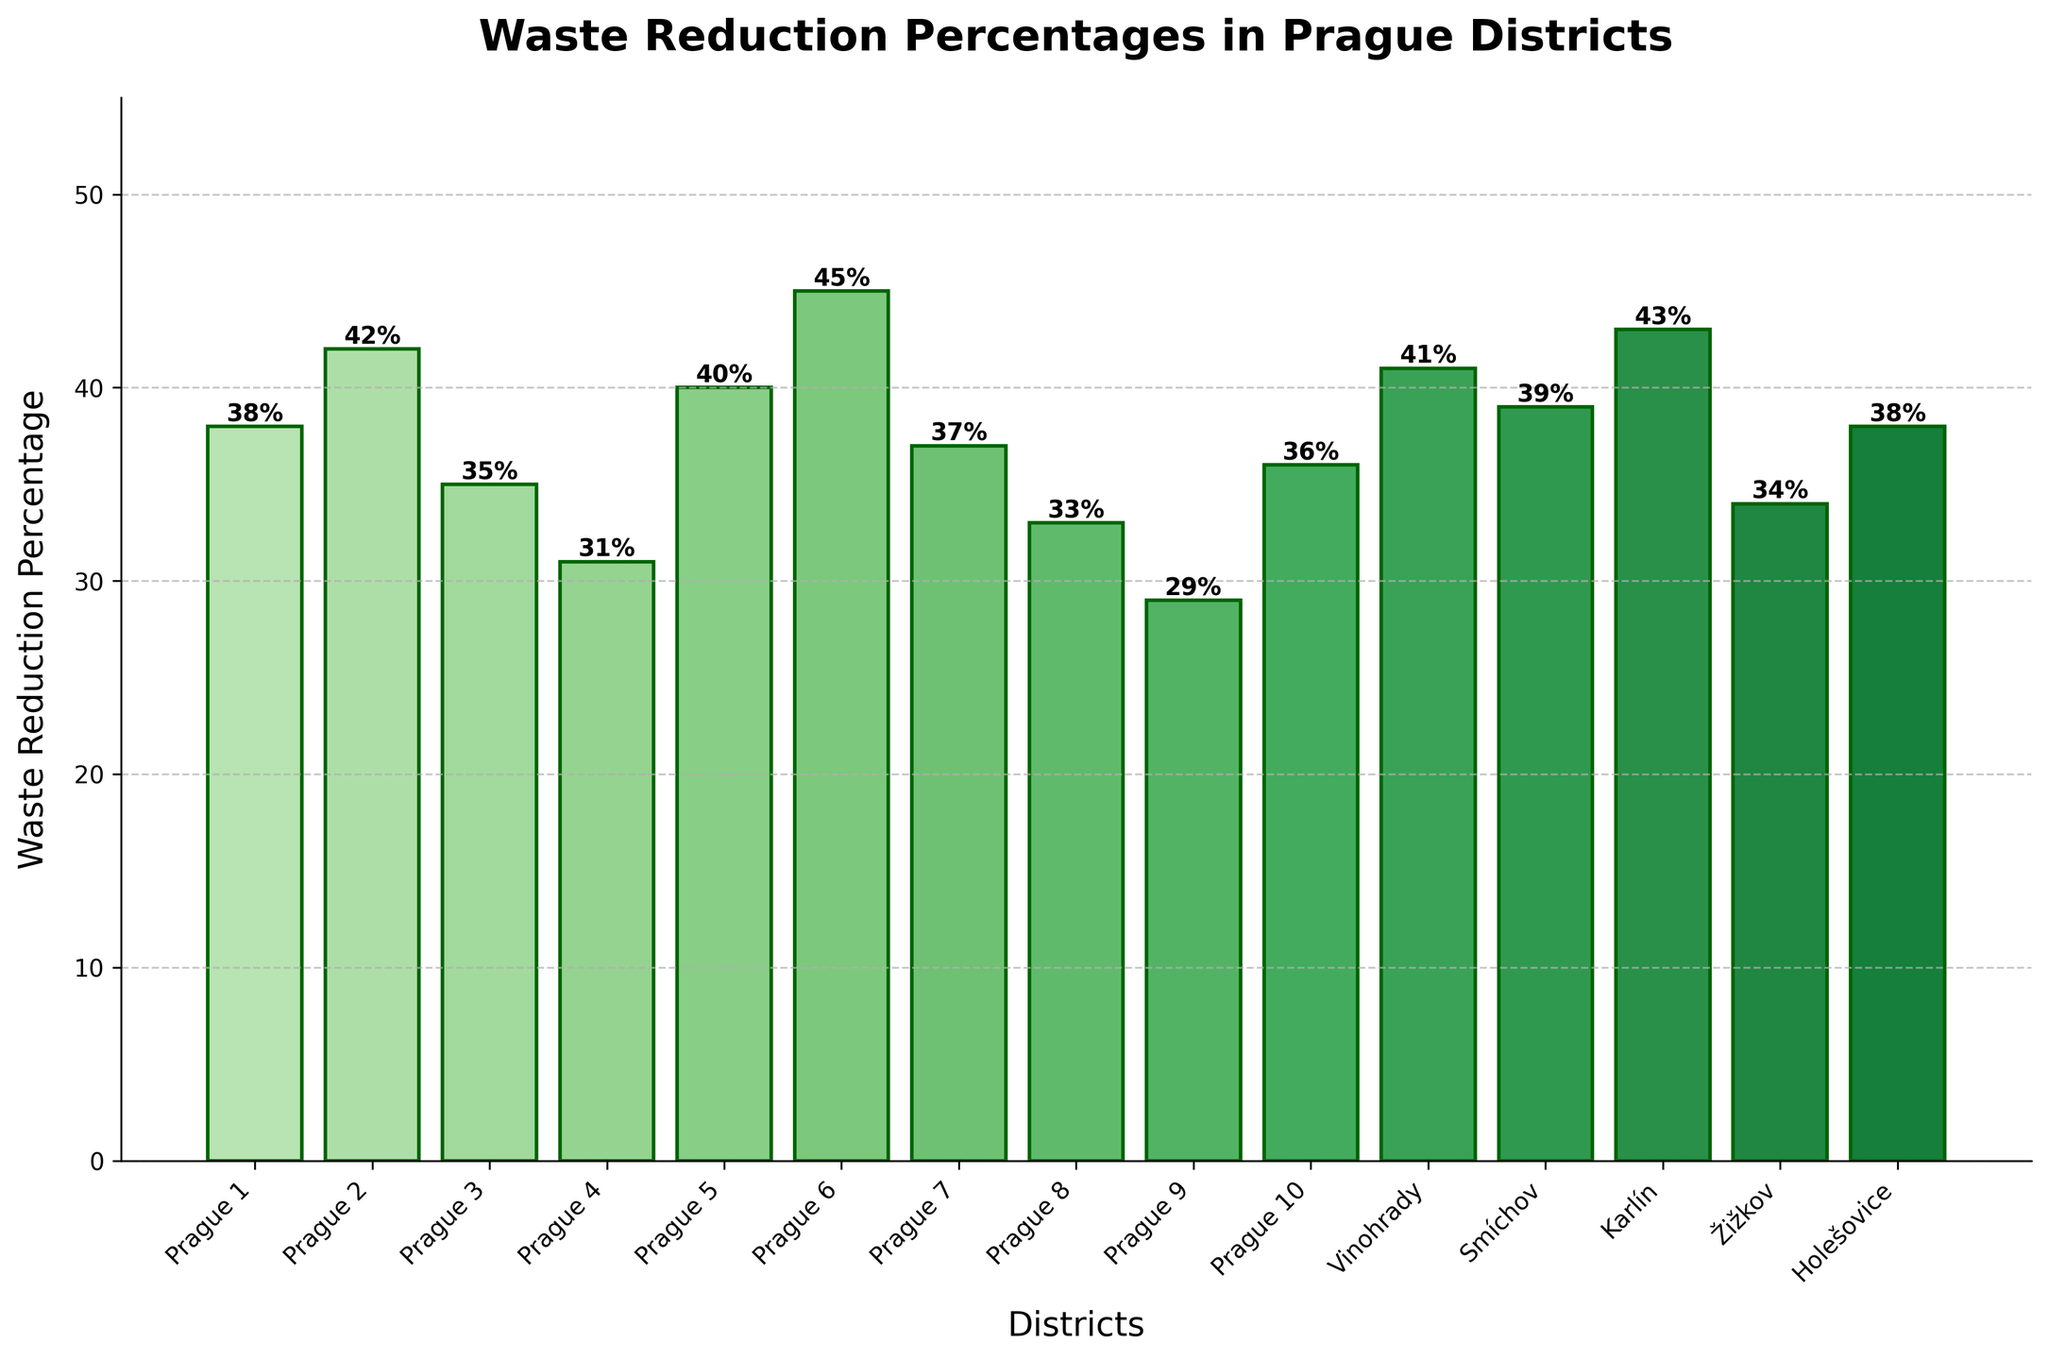Which district has the highest waste reduction percentage? First, locate the highest bar visually, which is the longest one. Then, read the label associated with that bar. In this case, Prague 6 has the highest waste reduction percentage with a value of 45%.
Answer: Prague 6 What is the difference in waste reduction percentage between Karlín and Žižkov? Karlín has a waste reduction percentage of 43%, and Žižkov has 34%. Subtract the latter from the former: 43 - 34 = 9%.
Answer: 9% Which districts have a waste reduction percentage below 35%? Identify the bars whose heights are below the 35% mark. The districts corresponding to these bars are Prague 4, Prague 8, and Prague 9.
Answer: Prague 4, Prague 8, Prague 9 Among Vinohrady, Smíchov, and Holešovice, which district has the lowest waste reduction percentage? Compare the heights of the bars for Vinohrady (41%), Smíchov (39%), and Holešovice (38%). Holešovice has the lowest percentage.
Answer: Holešovice What is the average waste reduction percentage across all districts? Add up all the percentages and divide by the number of districts:
(38 + 42 + 35 + 31 + 40 + 45 + 37 + 33 + 29 + 36 + 41 + 39 + 43 + 34 + 38) / 15 = 37.267%.
Answer: 37.27% How many districts have a waste reduction percentage above 40%? Count the bars that exceed the 40% height mark. These districts are Prague 2, Prague 5, Prague 6, Vinohrady, and Karlín.
Answer: 5 Which three districts have the closest waste reduction percentages? Compare the heights of the bars to find similar heights. Prague 1 (38%), Holešovice (38%), and Smíchov (39%) have close percentages.
Answer: Prague 1, Holešovice, Smíchov What is the range of waste reduction percentages across all districts? Identify the highest and lowest percentages: highest is 45% (Prague 6) and lowest is 29% (Prague 9). Subtract the lowest from the highest: 45 - 29 = 16%.
Answer: 16% Which district shows a waste reduction percentage equal to or closest to 33%? Identify the bar that reaches closest to the 33% mark. Prague 8 has a waste reduction percentage of exactly 33%.
Answer: Prague 8 